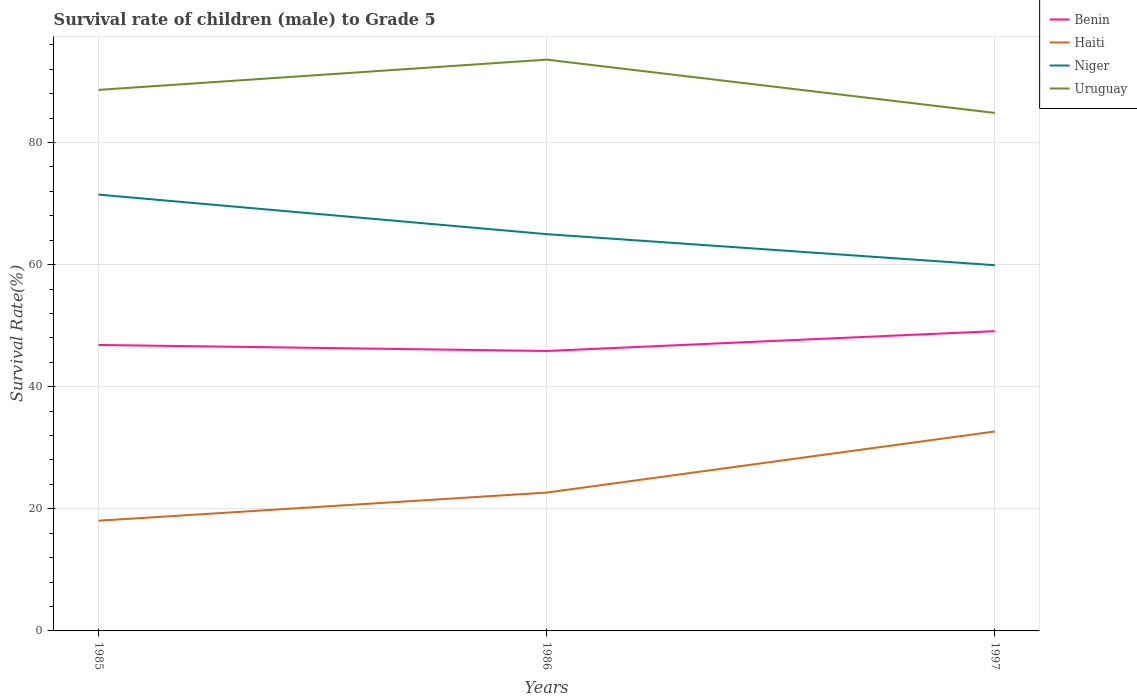How many different coloured lines are there?
Offer a terse response. 4. Does the line corresponding to Haiti intersect with the line corresponding to Benin?
Make the answer very short. No. Is the number of lines equal to the number of legend labels?
Provide a succinct answer. Yes. Across all years, what is the maximum survival rate of male children to grade 5 in Niger?
Your answer should be compact. 59.91. In which year was the survival rate of male children to grade 5 in Haiti maximum?
Provide a short and direct response. 1985. What is the total survival rate of male children to grade 5 in Niger in the graph?
Your answer should be very brief. 6.48. What is the difference between the highest and the second highest survival rate of male children to grade 5 in Uruguay?
Provide a short and direct response. 8.73. What is the difference between the highest and the lowest survival rate of male children to grade 5 in Uruguay?
Give a very brief answer. 1. How many years are there in the graph?
Your answer should be compact. 3. What is the difference between two consecutive major ticks on the Y-axis?
Keep it short and to the point. 20. Are the values on the major ticks of Y-axis written in scientific E-notation?
Offer a very short reply. No. What is the title of the graph?
Make the answer very short. Survival rate of children (male) to Grade 5. Does "Bhutan" appear as one of the legend labels in the graph?
Offer a very short reply. No. What is the label or title of the X-axis?
Provide a short and direct response. Years. What is the label or title of the Y-axis?
Your response must be concise. Survival Rate(%). What is the Survival Rate(%) of Benin in 1985?
Keep it short and to the point. 46.84. What is the Survival Rate(%) of Haiti in 1985?
Provide a short and direct response. 18.06. What is the Survival Rate(%) of Niger in 1985?
Keep it short and to the point. 71.47. What is the Survival Rate(%) in Uruguay in 1985?
Offer a very short reply. 88.63. What is the Survival Rate(%) of Benin in 1986?
Ensure brevity in your answer.  45.86. What is the Survival Rate(%) in Haiti in 1986?
Provide a short and direct response. 22.66. What is the Survival Rate(%) of Niger in 1986?
Give a very brief answer. 65. What is the Survival Rate(%) in Uruguay in 1986?
Make the answer very short. 93.58. What is the Survival Rate(%) of Benin in 1997?
Provide a succinct answer. 49.1. What is the Survival Rate(%) of Haiti in 1997?
Your answer should be very brief. 32.67. What is the Survival Rate(%) of Niger in 1997?
Keep it short and to the point. 59.91. What is the Survival Rate(%) in Uruguay in 1997?
Your response must be concise. 84.85. Across all years, what is the maximum Survival Rate(%) in Benin?
Offer a terse response. 49.1. Across all years, what is the maximum Survival Rate(%) in Haiti?
Provide a succinct answer. 32.67. Across all years, what is the maximum Survival Rate(%) in Niger?
Give a very brief answer. 71.47. Across all years, what is the maximum Survival Rate(%) in Uruguay?
Give a very brief answer. 93.58. Across all years, what is the minimum Survival Rate(%) of Benin?
Offer a terse response. 45.86. Across all years, what is the minimum Survival Rate(%) in Haiti?
Provide a succinct answer. 18.06. Across all years, what is the minimum Survival Rate(%) of Niger?
Provide a short and direct response. 59.91. Across all years, what is the minimum Survival Rate(%) of Uruguay?
Ensure brevity in your answer.  84.85. What is the total Survival Rate(%) of Benin in the graph?
Your answer should be compact. 141.81. What is the total Survival Rate(%) of Haiti in the graph?
Your answer should be compact. 73.39. What is the total Survival Rate(%) in Niger in the graph?
Your answer should be very brief. 196.38. What is the total Survival Rate(%) in Uruguay in the graph?
Provide a succinct answer. 267.07. What is the difference between the Survival Rate(%) in Benin in 1985 and that in 1986?
Provide a succinct answer. 0.98. What is the difference between the Survival Rate(%) of Haiti in 1985 and that in 1986?
Keep it short and to the point. -4.61. What is the difference between the Survival Rate(%) in Niger in 1985 and that in 1986?
Ensure brevity in your answer.  6.48. What is the difference between the Survival Rate(%) of Uruguay in 1985 and that in 1986?
Offer a terse response. -4.96. What is the difference between the Survival Rate(%) of Benin in 1985 and that in 1997?
Your answer should be very brief. -2.26. What is the difference between the Survival Rate(%) in Haiti in 1985 and that in 1997?
Ensure brevity in your answer.  -14.62. What is the difference between the Survival Rate(%) in Niger in 1985 and that in 1997?
Offer a very short reply. 11.56. What is the difference between the Survival Rate(%) of Uruguay in 1985 and that in 1997?
Give a very brief answer. 3.77. What is the difference between the Survival Rate(%) in Benin in 1986 and that in 1997?
Provide a short and direct response. -3.24. What is the difference between the Survival Rate(%) in Haiti in 1986 and that in 1997?
Offer a terse response. -10.01. What is the difference between the Survival Rate(%) of Niger in 1986 and that in 1997?
Your answer should be compact. 5.09. What is the difference between the Survival Rate(%) in Uruguay in 1986 and that in 1997?
Keep it short and to the point. 8.73. What is the difference between the Survival Rate(%) in Benin in 1985 and the Survival Rate(%) in Haiti in 1986?
Give a very brief answer. 24.18. What is the difference between the Survival Rate(%) of Benin in 1985 and the Survival Rate(%) of Niger in 1986?
Your answer should be very brief. -18.15. What is the difference between the Survival Rate(%) of Benin in 1985 and the Survival Rate(%) of Uruguay in 1986?
Provide a short and direct response. -46.74. What is the difference between the Survival Rate(%) of Haiti in 1985 and the Survival Rate(%) of Niger in 1986?
Provide a succinct answer. -46.94. What is the difference between the Survival Rate(%) in Haiti in 1985 and the Survival Rate(%) in Uruguay in 1986?
Provide a succinct answer. -75.53. What is the difference between the Survival Rate(%) in Niger in 1985 and the Survival Rate(%) in Uruguay in 1986?
Your response must be concise. -22.11. What is the difference between the Survival Rate(%) in Benin in 1985 and the Survival Rate(%) in Haiti in 1997?
Make the answer very short. 14.17. What is the difference between the Survival Rate(%) of Benin in 1985 and the Survival Rate(%) of Niger in 1997?
Give a very brief answer. -13.06. What is the difference between the Survival Rate(%) of Benin in 1985 and the Survival Rate(%) of Uruguay in 1997?
Provide a short and direct response. -38.01. What is the difference between the Survival Rate(%) in Haiti in 1985 and the Survival Rate(%) in Niger in 1997?
Your answer should be compact. -41.85. What is the difference between the Survival Rate(%) of Haiti in 1985 and the Survival Rate(%) of Uruguay in 1997?
Provide a short and direct response. -66.8. What is the difference between the Survival Rate(%) of Niger in 1985 and the Survival Rate(%) of Uruguay in 1997?
Provide a succinct answer. -13.38. What is the difference between the Survival Rate(%) in Benin in 1986 and the Survival Rate(%) in Haiti in 1997?
Make the answer very short. 13.19. What is the difference between the Survival Rate(%) of Benin in 1986 and the Survival Rate(%) of Niger in 1997?
Provide a succinct answer. -14.05. What is the difference between the Survival Rate(%) of Benin in 1986 and the Survival Rate(%) of Uruguay in 1997?
Offer a terse response. -38.99. What is the difference between the Survival Rate(%) of Haiti in 1986 and the Survival Rate(%) of Niger in 1997?
Ensure brevity in your answer.  -37.25. What is the difference between the Survival Rate(%) in Haiti in 1986 and the Survival Rate(%) in Uruguay in 1997?
Offer a very short reply. -62.19. What is the difference between the Survival Rate(%) of Niger in 1986 and the Survival Rate(%) of Uruguay in 1997?
Keep it short and to the point. -19.86. What is the average Survival Rate(%) in Benin per year?
Provide a short and direct response. 47.27. What is the average Survival Rate(%) of Haiti per year?
Offer a terse response. 24.46. What is the average Survival Rate(%) in Niger per year?
Give a very brief answer. 65.46. What is the average Survival Rate(%) of Uruguay per year?
Keep it short and to the point. 89.02. In the year 1985, what is the difference between the Survival Rate(%) in Benin and Survival Rate(%) in Haiti?
Ensure brevity in your answer.  28.79. In the year 1985, what is the difference between the Survival Rate(%) of Benin and Survival Rate(%) of Niger?
Ensure brevity in your answer.  -24.63. In the year 1985, what is the difference between the Survival Rate(%) of Benin and Survival Rate(%) of Uruguay?
Your response must be concise. -41.78. In the year 1985, what is the difference between the Survival Rate(%) in Haiti and Survival Rate(%) in Niger?
Your response must be concise. -53.42. In the year 1985, what is the difference between the Survival Rate(%) of Haiti and Survival Rate(%) of Uruguay?
Offer a terse response. -70.57. In the year 1985, what is the difference between the Survival Rate(%) of Niger and Survival Rate(%) of Uruguay?
Keep it short and to the point. -17.16. In the year 1986, what is the difference between the Survival Rate(%) of Benin and Survival Rate(%) of Haiti?
Ensure brevity in your answer.  23.2. In the year 1986, what is the difference between the Survival Rate(%) in Benin and Survival Rate(%) in Niger?
Keep it short and to the point. -19.14. In the year 1986, what is the difference between the Survival Rate(%) of Benin and Survival Rate(%) of Uruguay?
Your answer should be compact. -47.72. In the year 1986, what is the difference between the Survival Rate(%) of Haiti and Survival Rate(%) of Niger?
Your answer should be compact. -42.33. In the year 1986, what is the difference between the Survival Rate(%) in Haiti and Survival Rate(%) in Uruguay?
Keep it short and to the point. -70.92. In the year 1986, what is the difference between the Survival Rate(%) in Niger and Survival Rate(%) in Uruguay?
Your answer should be very brief. -28.59. In the year 1997, what is the difference between the Survival Rate(%) of Benin and Survival Rate(%) of Haiti?
Provide a succinct answer. 16.43. In the year 1997, what is the difference between the Survival Rate(%) of Benin and Survival Rate(%) of Niger?
Make the answer very short. -10.81. In the year 1997, what is the difference between the Survival Rate(%) of Benin and Survival Rate(%) of Uruguay?
Offer a very short reply. -35.75. In the year 1997, what is the difference between the Survival Rate(%) of Haiti and Survival Rate(%) of Niger?
Offer a terse response. -27.24. In the year 1997, what is the difference between the Survival Rate(%) of Haiti and Survival Rate(%) of Uruguay?
Offer a terse response. -52.18. In the year 1997, what is the difference between the Survival Rate(%) of Niger and Survival Rate(%) of Uruguay?
Give a very brief answer. -24.95. What is the ratio of the Survival Rate(%) in Benin in 1985 to that in 1986?
Offer a very short reply. 1.02. What is the ratio of the Survival Rate(%) in Haiti in 1985 to that in 1986?
Your answer should be compact. 0.8. What is the ratio of the Survival Rate(%) in Niger in 1985 to that in 1986?
Offer a very short reply. 1.1. What is the ratio of the Survival Rate(%) of Uruguay in 1985 to that in 1986?
Ensure brevity in your answer.  0.95. What is the ratio of the Survival Rate(%) in Benin in 1985 to that in 1997?
Offer a terse response. 0.95. What is the ratio of the Survival Rate(%) of Haiti in 1985 to that in 1997?
Your response must be concise. 0.55. What is the ratio of the Survival Rate(%) in Niger in 1985 to that in 1997?
Offer a terse response. 1.19. What is the ratio of the Survival Rate(%) in Uruguay in 1985 to that in 1997?
Give a very brief answer. 1.04. What is the ratio of the Survival Rate(%) in Benin in 1986 to that in 1997?
Provide a succinct answer. 0.93. What is the ratio of the Survival Rate(%) in Haiti in 1986 to that in 1997?
Keep it short and to the point. 0.69. What is the ratio of the Survival Rate(%) of Niger in 1986 to that in 1997?
Offer a terse response. 1.08. What is the ratio of the Survival Rate(%) of Uruguay in 1986 to that in 1997?
Ensure brevity in your answer.  1.1. What is the difference between the highest and the second highest Survival Rate(%) of Benin?
Your answer should be compact. 2.26. What is the difference between the highest and the second highest Survival Rate(%) in Haiti?
Ensure brevity in your answer.  10.01. What is the difference between the highest and the second highest Survival Rate(%) in Niger?
Provide a succinct answer. 6.48. What is the difference between the highest and the second highest Survival Rate(%) of Uruguay?
Your answer should be compact. 4.96. What is the difference between the highest and the lowest Survival Rate(%) of Benin?
Make the answer very short. 3.24. What is the difference between the highest and the lowest Survival Rate(%) of Haiti?
Give a very brief answer. 14.62. What is the difference between the highest and the lowest Survival Rate(%) of Niger?
Your response must be concise. 11.56. What is the difference between the highest and the lowest Survival Rate(%) in Uruguay?
Keep it short and to the point. 8.73. 